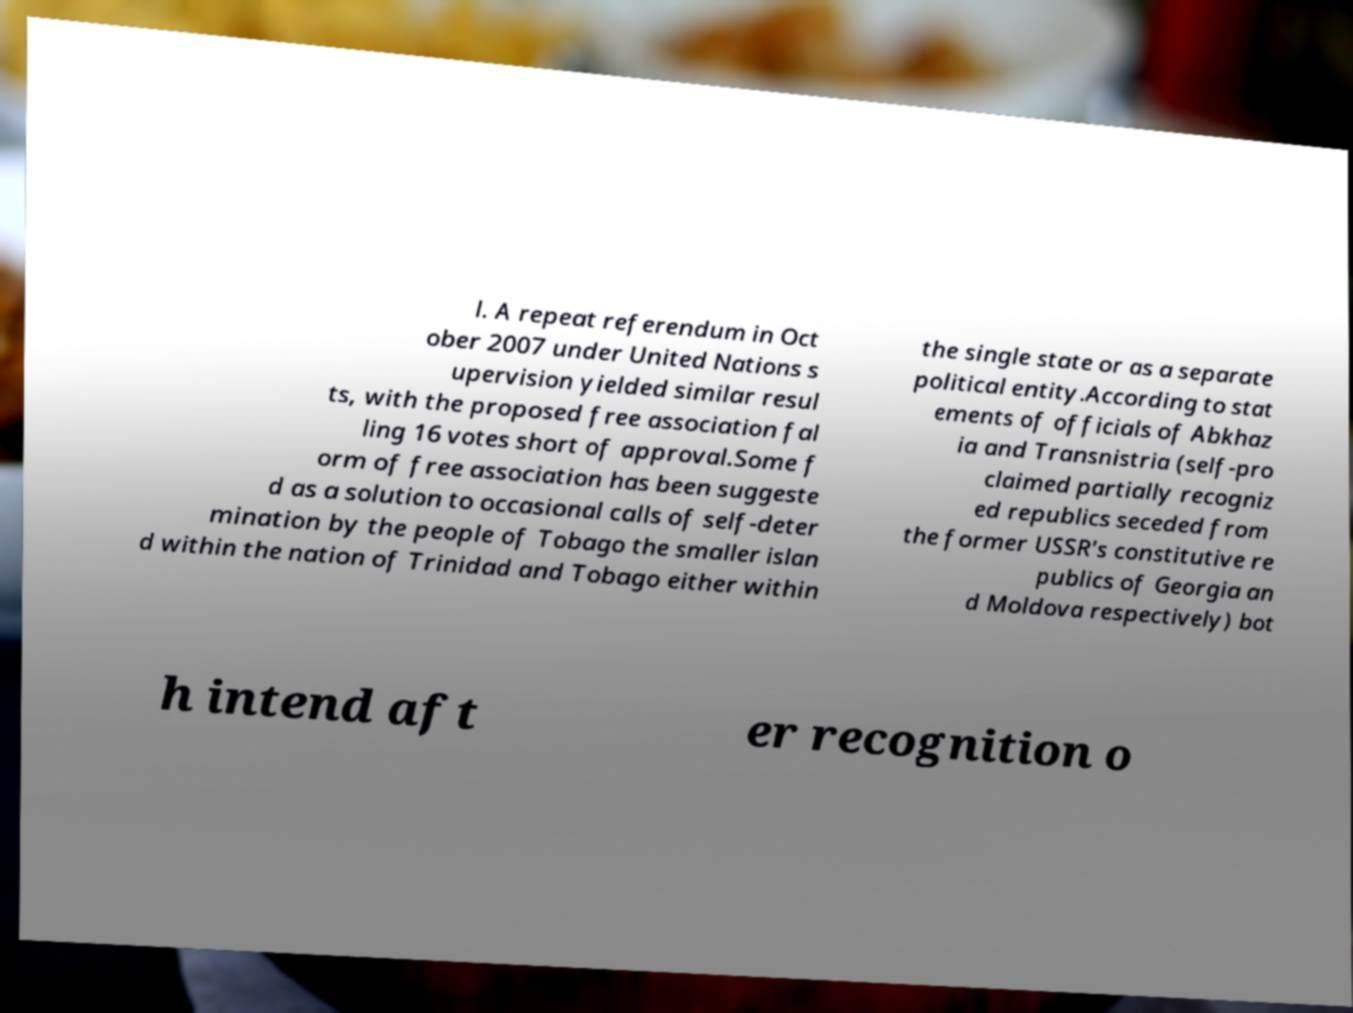I need the written content from this picture converted into text. Can you do that? l. A repeat referendum in Oct ober 2007 under United Nations s upervision yielded similar resul ts, with the proposed free association fal ling 16 votes short of approval.Some f orm of free association has been suggeste d as a solution to occasional calls of self-deter mination by the people of Tobago the smaller islan d within the nation of Trinidad and Tobago either within the single state or as a separate political entity.According to stat ements of officials of Abkhaz ia and Transnistria (self-pro claimed partially recogniz ed republics seceded from the former USSR's constitutive re publics of Georgia an d Moldova respectively) bot h intend aft er recognition o 